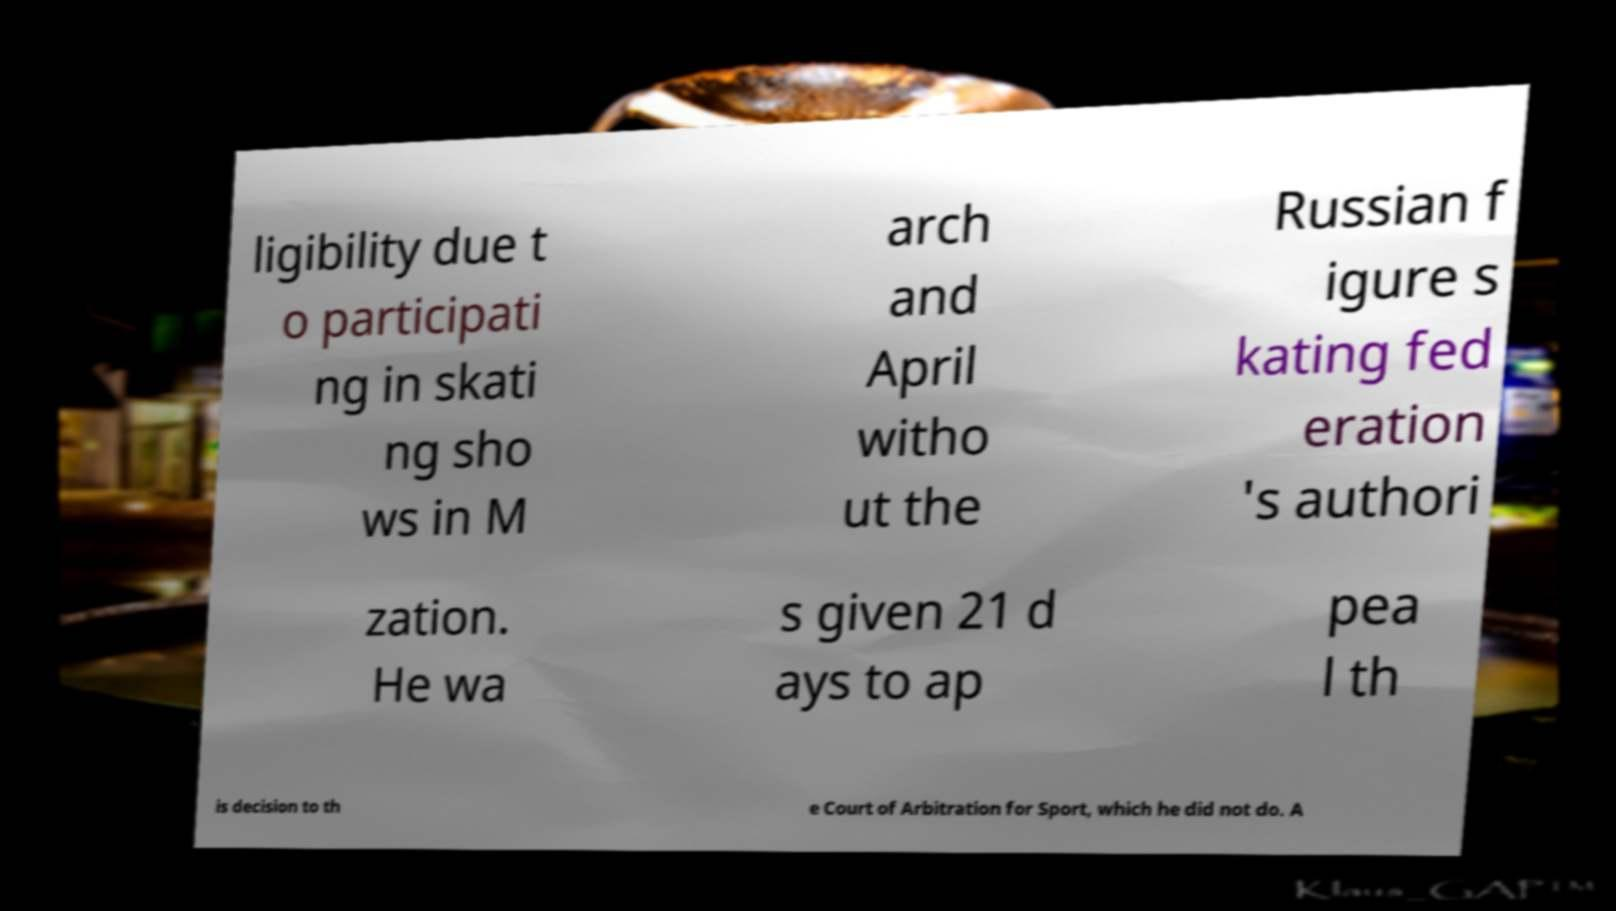Can you read and provide the text displayed in the image?This photo seems to have some interesting text. Can you extract and type it out for me? ligibility due t o participati ng in skati ng sho ws in M arch and April witho ut the Russian f igure s kating fed eration 's authori zation. He wa s given 21 d ays to ap pea l th is decision to th e Court of Arbitration for Sport, which he did not do. A 